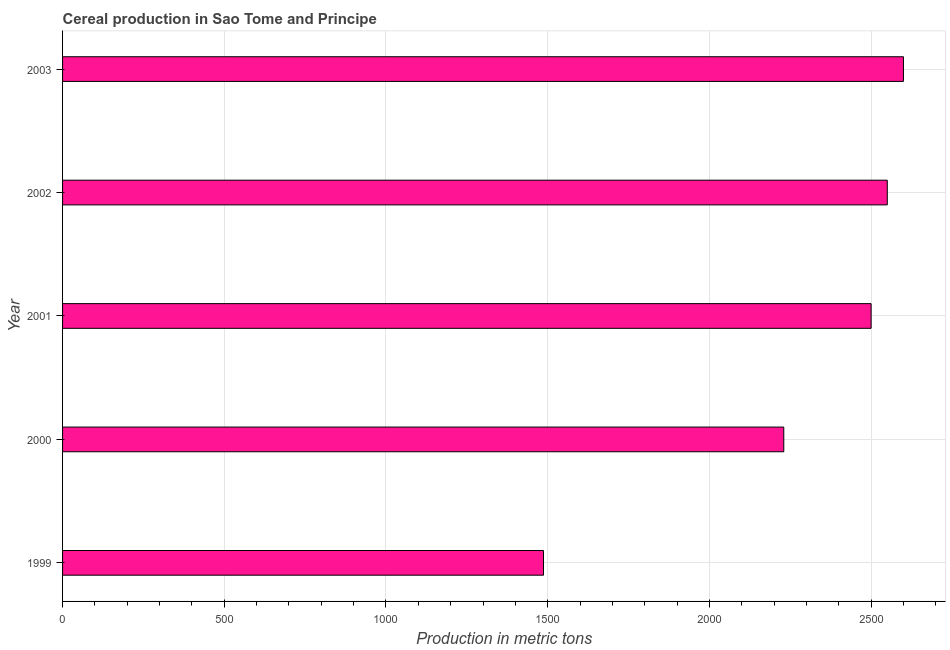Does the graph contain any zero values?
Ensure brevity in your answer.  No. Does the graph contain grids?
Your response must be concise. Yes. What is the title of the graph?
Make the answer very short. Cereal production in Sao Tome and Principe. What is the label or title of the X-axis?
Keep it short and to the point. Production in metric tons. What is the cereal production in 2001?
Offer a very short reply. 2500. Across all years, what is the maximum cereal production?
Offer a terse response. 2600. Across all years, what is the minimum cereal production?
Your response must be concise. 1487. What is the sum of the cereal production?
Your response must be concise. 1.14e+04. What is the difference between the cereal production in 1999 and 2002?
Make the answer very short. -1063. What is the average cereal production per year?
Your answer should be very brief. 2273.4. What is the median cereal production?
Your answer should be very brief. 2500. Do a majority of the years between 1999 and 2003 (inclusive) have cereal production greater than 2600 metric tons?
Your answer should be very brief. No. What is the ratio of the cereal production in 2000 to that in 2003?
Ensure brevity in your answer.  0.86. Is the cereal production in 2001 less than that in 2002?
Provide a short and direct response. Yes. Is the difference between the cereal production in 1999 and 2000 greater than the difference between any two years?
Make the answer very short. No. What is the difference between the highest and the second highest cereal production?
Provide a succinct answer. 50. Is the sum of the cereal production in 1999 and 2003 greater than the maximum cereal production across all years?
Make the answer very short. Yes. What is the difference between the highest and the lowest cereal production?
Ensure brevity in your answer.  1113. In how many years, is the cereal production greater than the average cereal production taken over all years?
Provide a short and direct response. 3. How many bars are there?
Provide a succinct answer. 5. Are all the bars in the graph horizontal?
Make the answer very short. Yes. Are the values on the major ticks of X-axis written in scientific E-notation?
Offer a terse response. No. What is the Production in metric tons in 1999?
Offer a very short reply. 1487. What is the Production in metric tons in 2000?
Ensure brevity in your answer.  2230. What is the Production in metric tons of 2001?
Provide a short and direct response. 2500. What is the Production in metric tons of 2002?
Provide a succinct answer. 2550. What is the Production in metric tons of 2003?
Keep it short and to the point. 2600. What is the difference between the Production in metric tons in 1999 and 2000?
Keep it short and to the point. -743. What is the difference between the Production in metric tons in 1999 and 2001?
Offer a very short reply. -1013. What is the difference between the Production in metric tons in 1999 and 2002?
Ensure brevity in your answer.  -1063. What is the difference between the Production in metric tons in 1999 and 2003?
Provide a succinct answer. -1113. What is the difference between the Production in metric tons in 2000 and 2001?
Provide a succinct answer. -270. What is the difference between the Production in metric tons in 2000 and 2002?
Ensure brevity in your answer.  -320. What is the difference between the Production in metric tons in 2000 and 2003?
Your answer should be very brief. -370. What is the difference between the Production in metric tons in 2001 and 2002?
Give a very brief answer. -50. What is the difference between the Production in metric tons in 2001 and 2003?
Offer a very short reply. -100. What is the difference between the Production in metric tons in 2002 and 2003?
Provide a short and direct response. -50. What is the ratio of the Production in metric tons in 1999 to that in 2000?
Your answer should be compact. 0.67. What is the ratio of the Production in metric tons in 1999 to that in 2001?
Your response must be concise. 0.59. What is the ratio of the Production in metric tons in 1999 to that in 2002?
Make the answer very short. 0.58. What is the ratio of the Production in metric tons in 1999 to that in 2003?
Provide a short and direct response. 0.57. What is the ratio of the Production in metric tons in 2000 to that in 2001?
Offer a very short reply. 0.89. What is the ratio of the Production in metric tons in 2000 to that in 2002?
Your answer should be compact. 0.88. What is the ratio of the Production in metric tons in 2000 to that in 2003?
Give a very brief answer. 0.86. What is the ratio of the Production in metric tons in 2001 to that in 2002?
Your response must be concise. 0.98. 